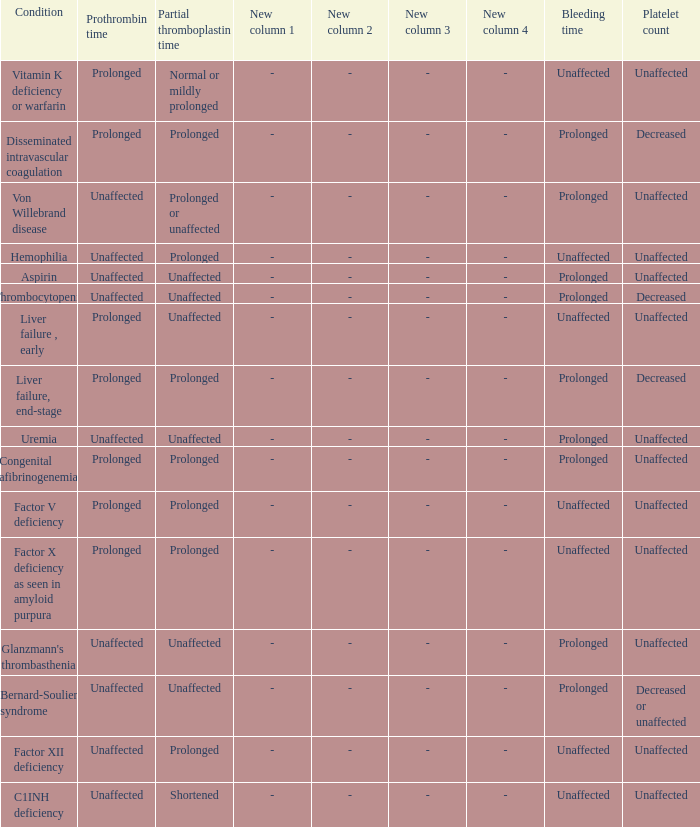Which Prothrombin time has a Platelet count of unaffected, and a Bleeding time of unaffected, and a Partial thromboplastin time of normal or mildly prolonged? Prolonged. 